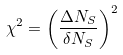<formula> <loc_0><loc_0><loc_500><loc_500>\chi ^ { 2 } = \left ( \frac { \Delta { N _ { S } } } { \delta N _ { S } } \right ) ^ { 2 }</formula> 